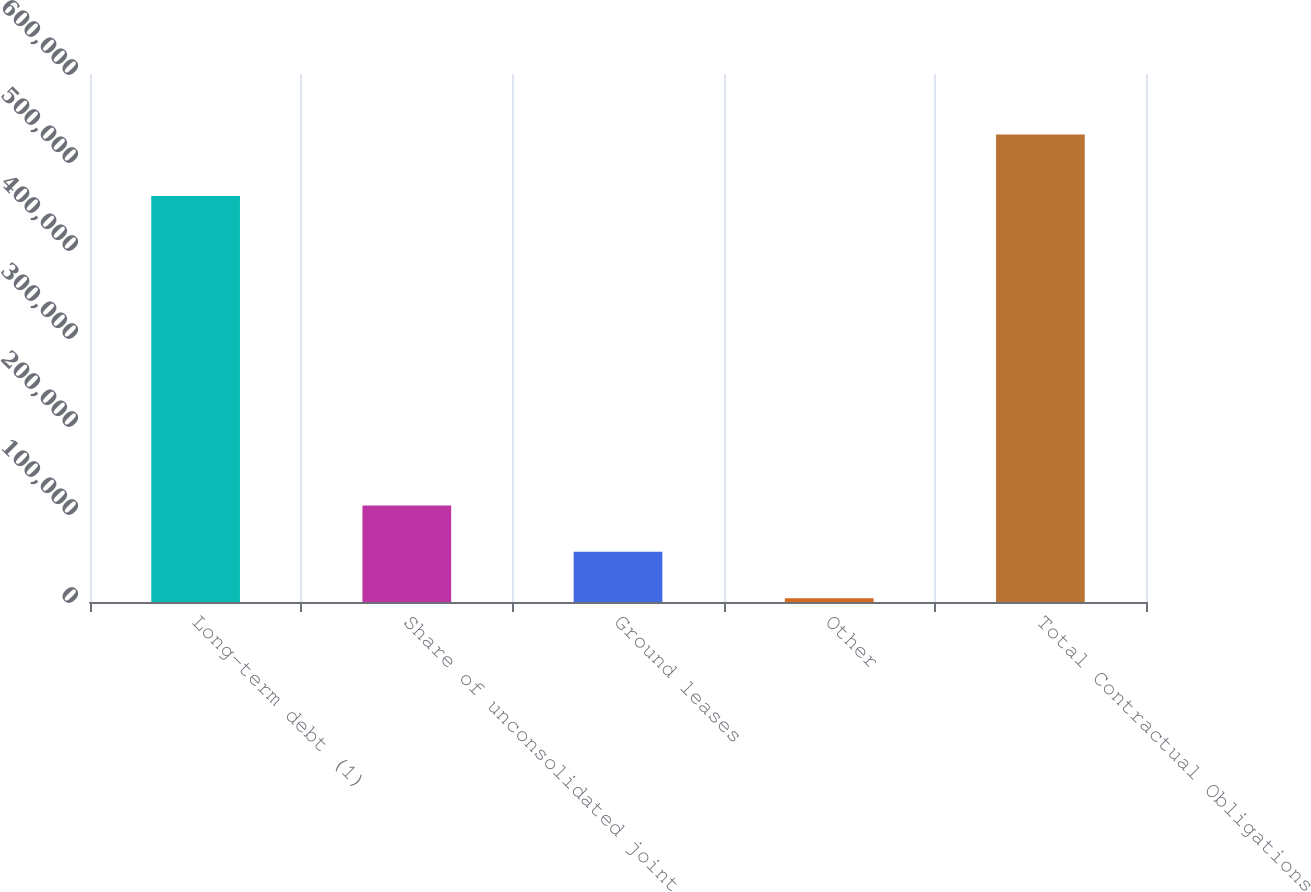<chart> <loc_0><loc_0><loc_500><loc_500><bar_chart><fcel>Long-term debt (1)<fcel>Share of unconsolidated joint<fcel>Ground leases<fcel>Other<fcel>Total Contractual Obligations<nl><fcel>461309<fcel>109701<fcel>57013.7<fcel>4326<fcel>531203<nl></chart> 